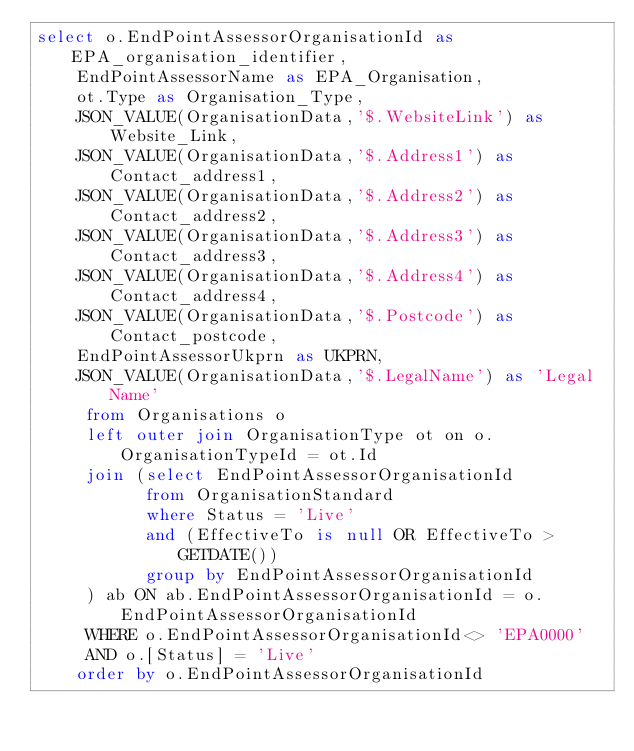Convert code to text. <code><loc_0><loc_0><loc_500><loc_500><_SQL_>select o.EndPointAssessorOrganisationId as EPA_organisation_identifier, 
    EndPointAssessorName as EPA_Organisation,
    ot.Type as Organisation_Type,
    JSON_VALUE(OrganisationData,'$.WebsiteLink') as Website_Link,
    JSON_VALUE(OrganisationData,'$.Address1') as Contact_address1,
    JSON_VALUE(OrganisationData,'$.Address2') as Contact_address2,
    JSON_VALUE(OrganisationData,'$.Address3') as Contact_address3,
    JSON_VALUE(OrganisationData,'$.Address4') as Contact_address4,
    JSON_VALUE(OrganisationData,'$.Postcode') as Contact_postcode,
    EndPointAssessorUkprn as UKPRN,
    JSON_VALUE(OrganisationData,'$.LegalName') as 'Legal Name'
     from Organisations o 
     left outer join OrganisationType ot on o.OrganisationTypeId = ot.Id
     join (select EndPointAssessorOrganisationId 
           from OrganisationStandard
           where Status = 'Live'
           and (EffectiveTo is null OR EffectiveTo > GETDATE())           
           group by EndPointAssessorOrganisationId
     ) ab ON ab.EndPointAssessorOrganisationId = o.EndPointAssessorOrganisationId
     WHERE o.EndPointAssessorOrganisationId<> 'EPA0000' 
     AND o.[Status] = 'Live'
    order by o.EndPointAssessorOrganisationId

</code> 